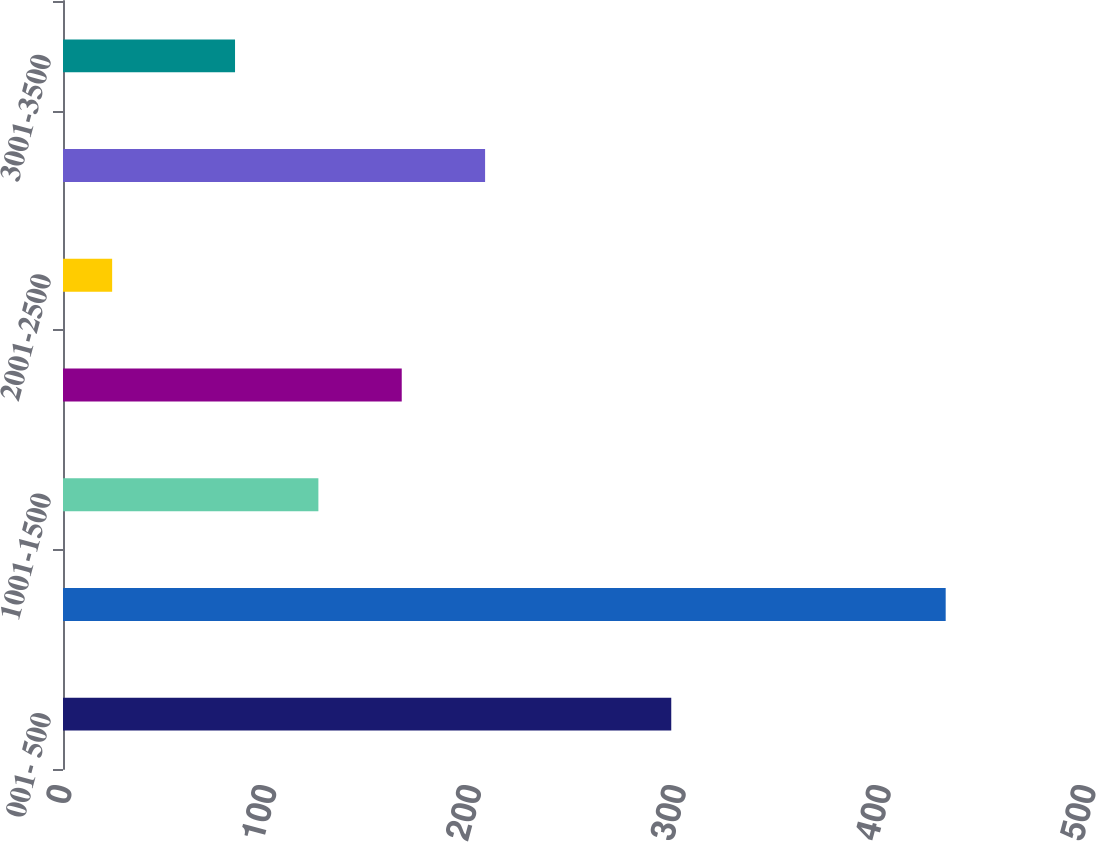<chart> <loc_0><loc_0><loc_500><loc_500><bar_chart><fcel>001- 500<fcel>501-1000<fcel>1001-1500<fcel>1501-2000<fcel>2001-2500<fcel>2501-3000<fcel>3001-3500<nl><fcel>297<fcel>431<fcel>124.7<fcel>165.4<fcel>24<fcel>206.1<fcel>84<nl></chart> 